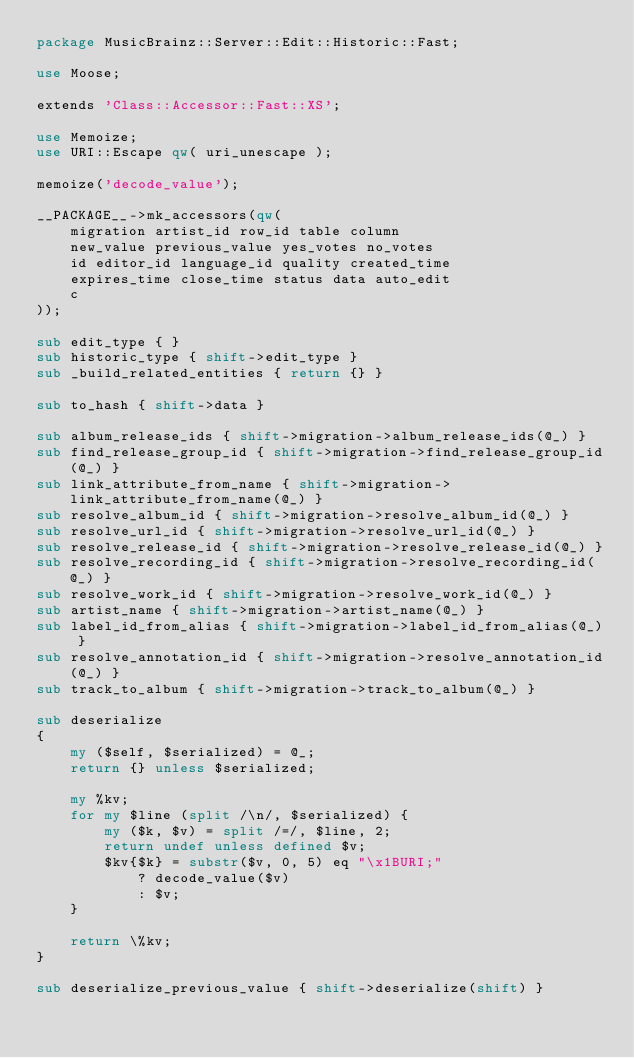<code> <loc_0><loc_0><loc_500><loc_500><_Perl_>package MusicBrainz::Server::Edit::Historic::Fast;

use Moose;

extends 'Class::Accessor::Fast::XS';

use Memoize;
use URI::Escape qw( uri_unescape );

memoize('decode_value');

__PACKAGE__->mk_accessors(qw(
    migration artist_id row_id table column
    new_value previous_value yes_votes no_votes
    id editor_id language_id quality created_time
    expires_time close_time status data auto_edit
    c
));

sub edit_type { }
sub historic_type { shift->edit_type }
sub _build_related_entities { return {} }

sub to_hash { shift->data }

sub album_release_ids { shift->migration->album_release_ids(@_) }
sub find_release_group_id { shift->migration->find_release_group_id(@_) }
sub link_attribute_from_name { shift->migration->link_attribute_from_name(@_) }
sub resolve_album_id { shift->migration->resolve_album_id(@_) }
sub resolve_url_id { shift->migration->resolve_url_id(@_) }
sub resolve_release_id { shift->migration->resolve_release_id(@_) }
sub resolve_recording_id { shift->migration->resolve_recording_id(@_) }
sub resolve_work_id { shift->migration->resolve_work_id(@_) }
sub artist_name { shift->migration->artist_name(@_) }
sub label_id_from_alias { shift->migration->label_id_from_alias(@_) }
sub resolve_annotation_id { shift->migration->resolve_annotation_id(@_) }
sub track_to_album { shift->migration->track_to_album(@_) }

sub deserialize
{
    my ($self, $serialized) = @_;
    return {} unless $serialized;

    my %kv;
    for my $line (split /\n/, $serialized) {
        my ($k, $v) = split /=/, $line, 2;
        return undef unless defined $v;
        $kv{$k} = substr($v, 0, 5) eq "\x1BURI;"
            ? decode_value($v)
            : $v;
    }

    return \%kv;
}

sub deserialize_previous_value { shift->deserialize(shift) }</code> 